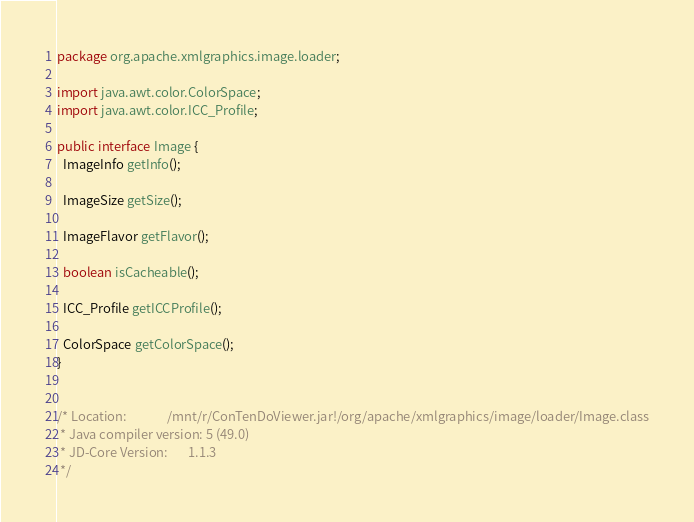<code> <loc_0><loc_0><loc_500><loc_500><_Java_>package org.apache.xmlgraphics.image.loader;

import java.awt.color.ColorSpace;
import java.awt.color.ICC_Profile;

public interface Image {
  ImageInfo getInfo();
  
  ImageSize getSize();
  
  ImageFlavor getFlavor();
  
  boolean isCacheable();
  
  ICC_Profile getICCProfile();
  
  ColorSpace getColorSpace();
}


/* Location:              /mnt/r/ConTenDoViewer.jar!/org/apache/xmlgraphics/image/loader/Image.class
 * Java compiler version: 5 (49.0)
 * JD-Core Version:       1.1.3
 */</code> 